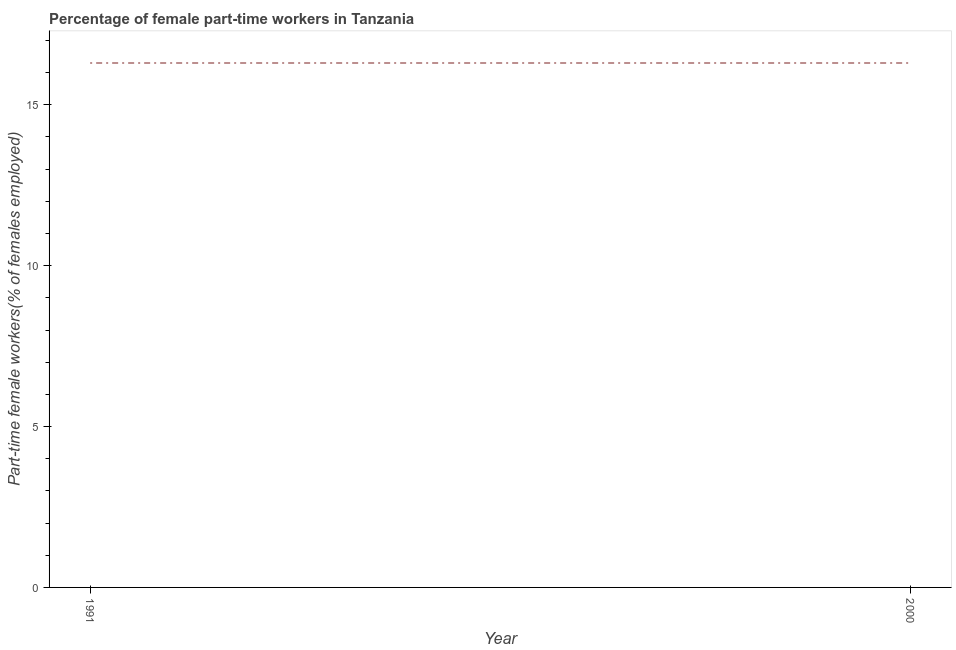What is the percentage of part-time female workers in 2000?
Provide a short and direct response. 16.3. Across all years, what is the maximum percentage of part-time female workers?
Make the answer very short. 16.3. Across all years, what is the minimum percentage of part-time female workers?
Keep it short and to the point. 16.3. In which year was the percentage of part-time female workers minimum?
Make the answer very short. 1991. What is the sum of the percentage of part-time female workers?
Ensure brevity in your answer.  32.6. What is the difference between the percentage of part-time female workers in 1991 and 2000?
Your answer should be very brief. 0. What is the average percentage of part-time female workers per year?
Your answer should be compact. 16.3. What is the median percentage of part-time female workers?
Make the answer very short. 16.3. In how many years, is the percentage of part-time female workers greater than 15 %?
Your answer should be very brief. 2. Do a majority of the years between 2000 and 1991 (inclusive) have percentage of part-time female workers greater than 14 %?
Your response must be concise. No. What is the ratio of the percentage of part-time female workers in 1991 to that in 2000?
Keep it short and to the point. 1. What is the difference between two consecutive major ticks on the Y-axis?
Make the answer very short. 5. Are the values on the major ticks of Y-axis written in scientific E-notation?
Make the answer very short. No. Does the graph contain any zero values?
Your answer should be very brief. No. What is the title of the graph?
Ensure brevity in your answer.  Percentage of female part-time workers in Tanzania. What is the label or title of the Y-axis?
Provide a succinct answer. Part-time female workers(% of females employed). What is the Part-time female workers(% of females employed) of 1991?
Ensure brevity in your answer.  16.3. What is the Part-time female workers(% of females employed) in 2000?
Offer a very short reply. 16.3. What is the difference between the Part-time female workers(% of females employed) in 1991 and 2000?
Make the answer very short. 0. What is the ratio of the Part-time female workers(% of females employed) in 1991 to that in 2000?
Your answer should be very brief. 1. 